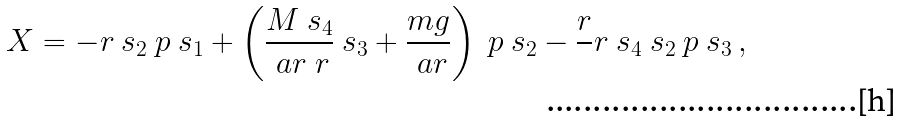<formula> <loc_0><loc_0><loc_500><loc_500>X = - r \ s _ { 2 } \ p { \ s _ { 1 } } + \left ( \frac { M \ s _ { 4 } } { \ a r \ r } \ s _ { 3 } + \frac { m g } { \ a r } \right ) \ p { \ s _ { 2 } } - \frac { r } { \ } r \ s _ { 4 } \ s _ { 2 } \ p { \ s _ { 3 } } \, ,</formula> 